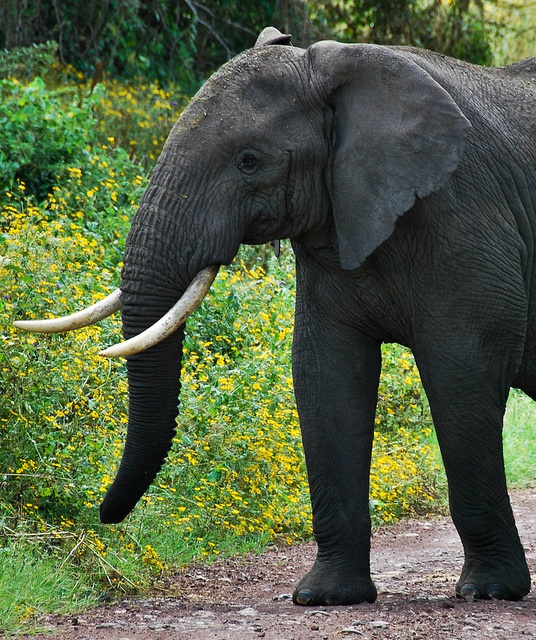Describe the objects in this image and their specific colors. I can see a elephant in black, gray, purple, and darkgray tones in this image. 